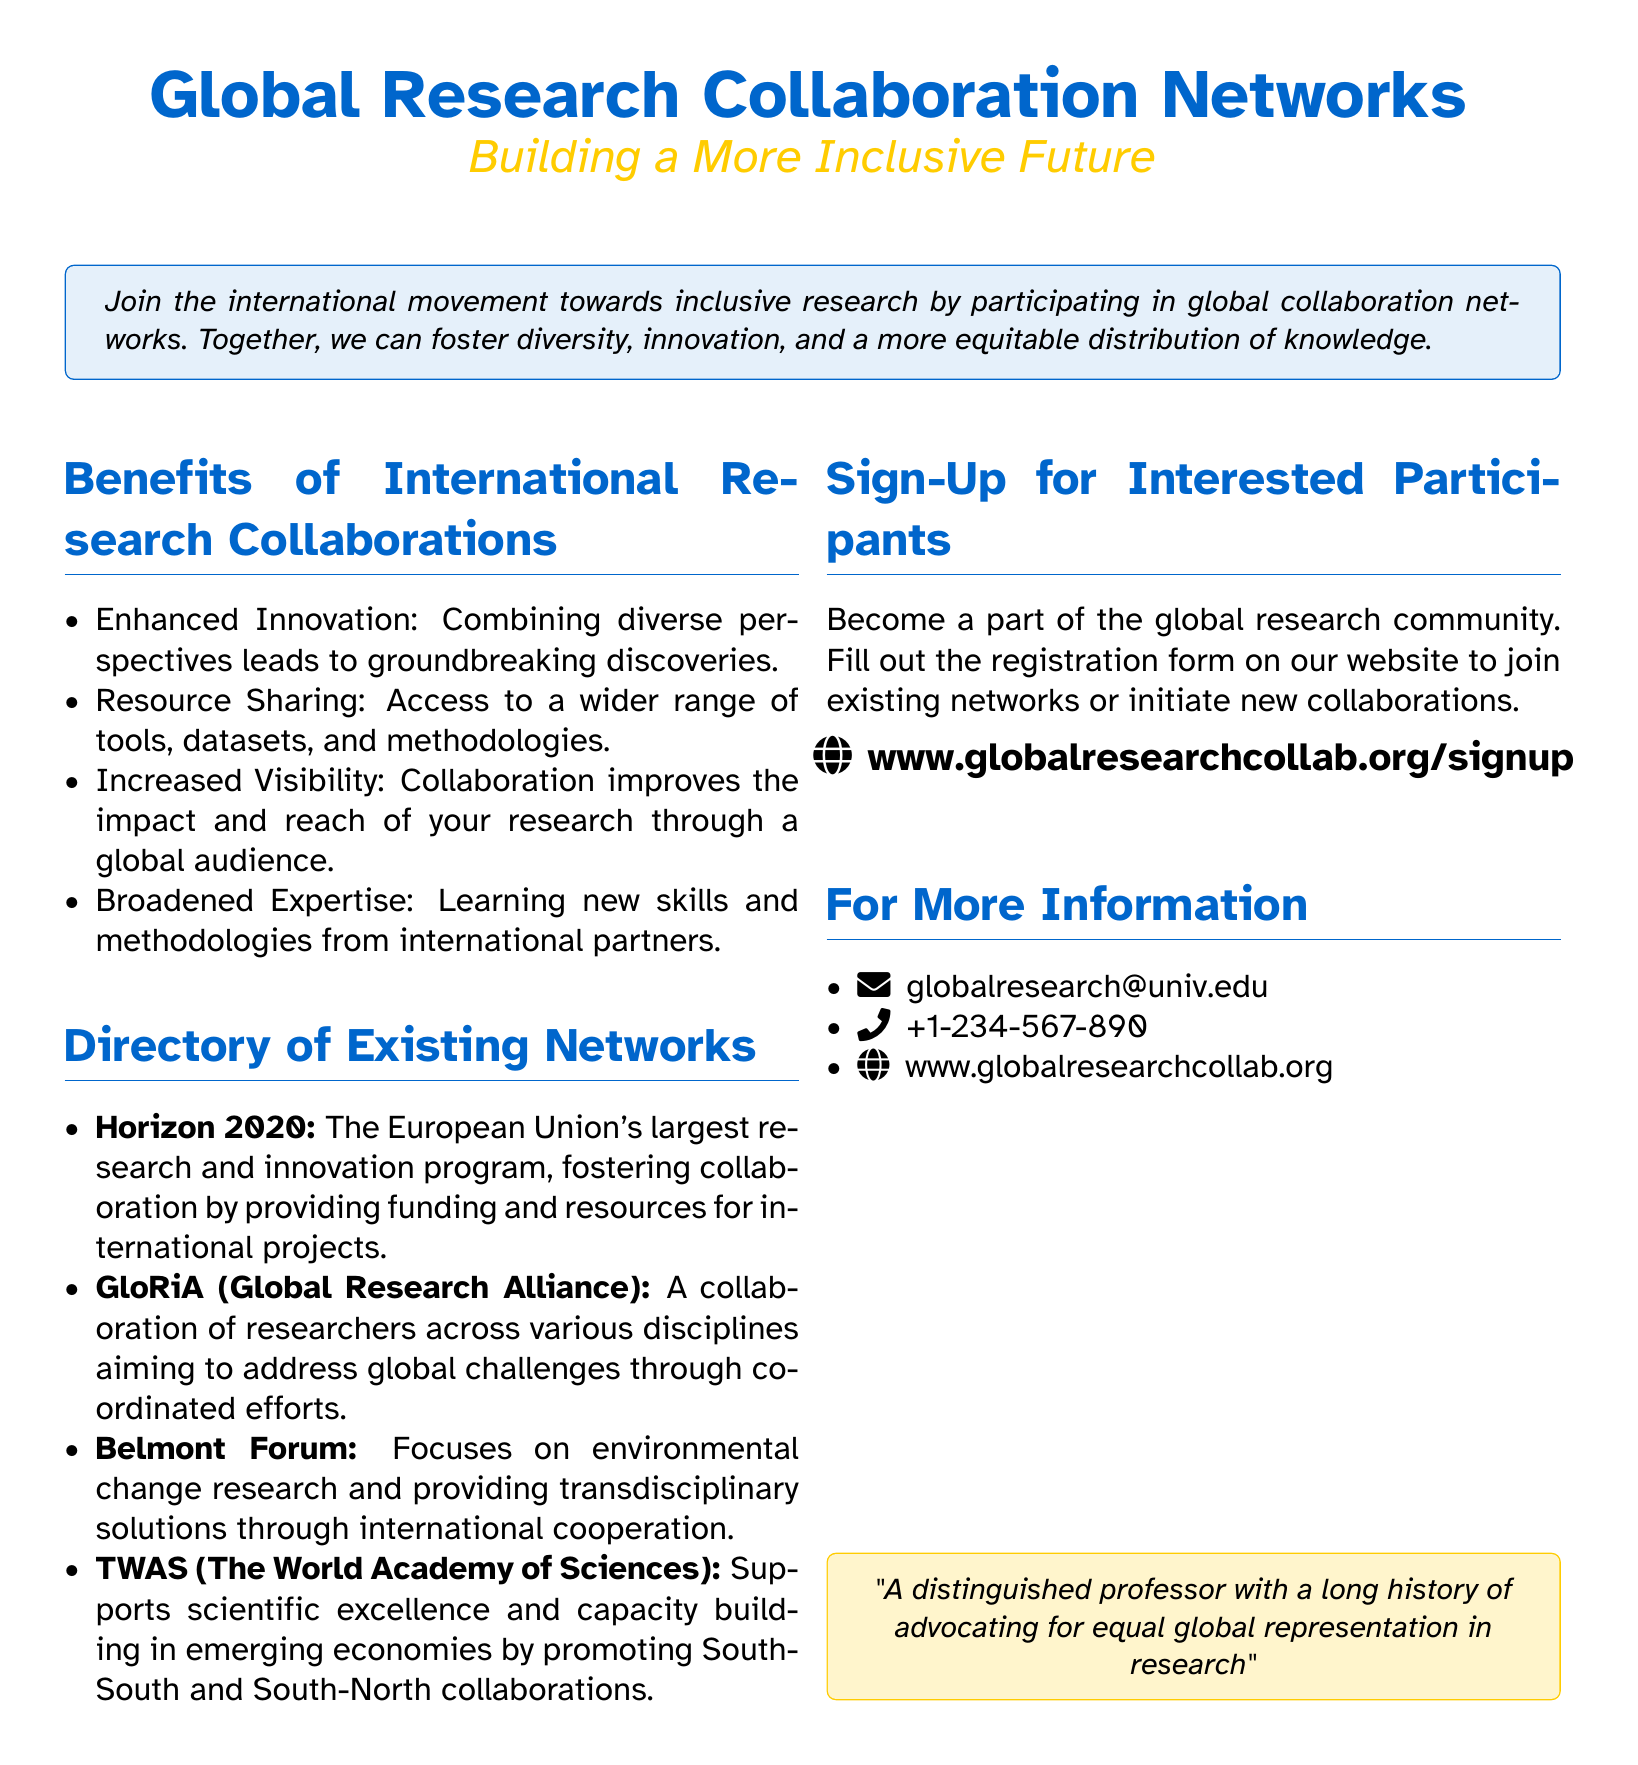What is the main theme of the flyer? The main theme is presented in the title, highlighting the focus on global research collaboration networks.
Answer: Global Research Collaboration Networks What benefits are listed for international research collaborations? The flyer enumerates several advantages of collaboration, aiming to improve understanding of its value.
Answer: Enhanced Innovation How many existing networks are mentioned in the directory? The document lists four existing research collaboration networks, indicating the variety available.
Answer: Four What is the website for sign-up? The flyer provides a direct URL for those interested in joining the collaboration networks, emphasizing accessibility.
Answer: www.globalresearchcollab.org/signup What is one of the contact methods listed for more information? The document includes multiple pathways for inquiry, making it easy for interested parties to reach out.
Answer: Email What type of collaboration does TWAS promote? This detail highlights the specific focus of TWAS in fostering partnerships, underlining its unique role among the listed networks.
Answer: South-South and South-North collaborations What does the tcolorbox at the end of the document communicate? The final tcolorbox reflects the identity and position of the individual advocating for the initiative, summarizing their influence.
Answer: Equal global representation in research 